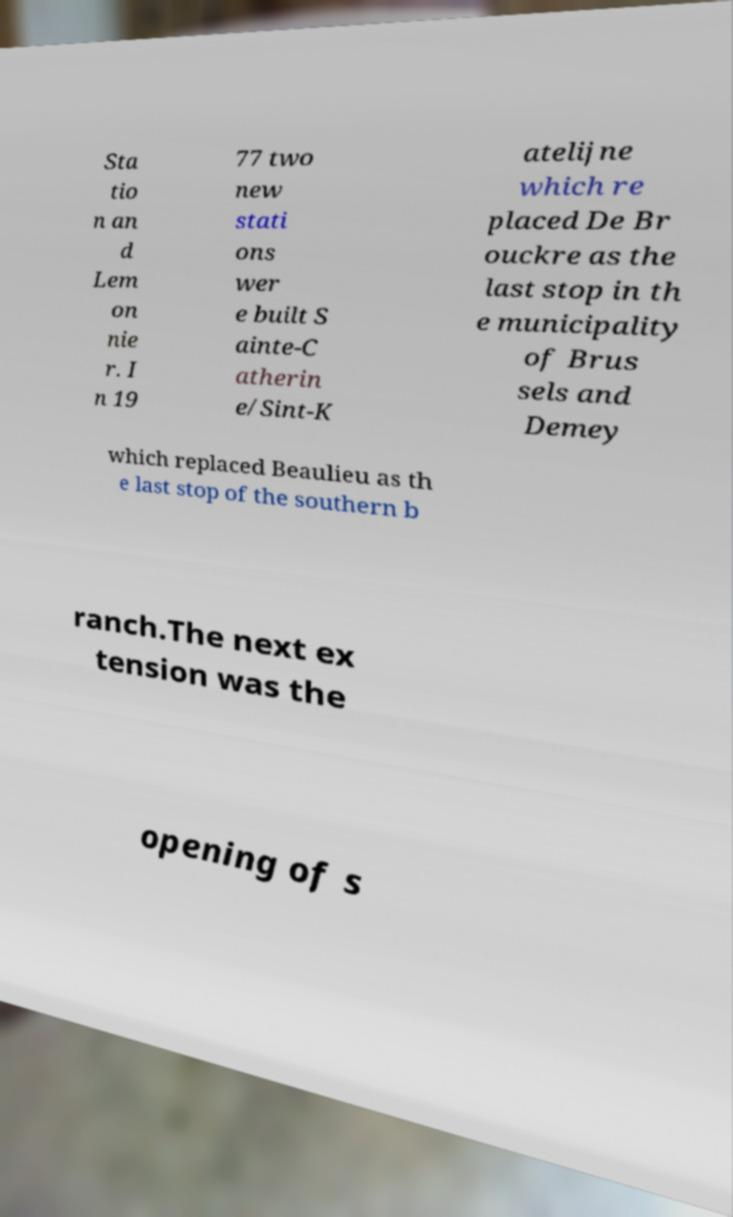For documentation purposes, I need the text within this image transcribed. Could you provide that? Sta tio n an d Lem on nie r. I n 19 77 two new stati ons wer e built S ainte-C atherin e/Sint-K atelijne which re placed De Br ouckre as the last stop in th e municipality of Brus sels and Demey which replaced Beaulieu as th e last stop of the southern b ranch.The next ex tension was the opening of s 